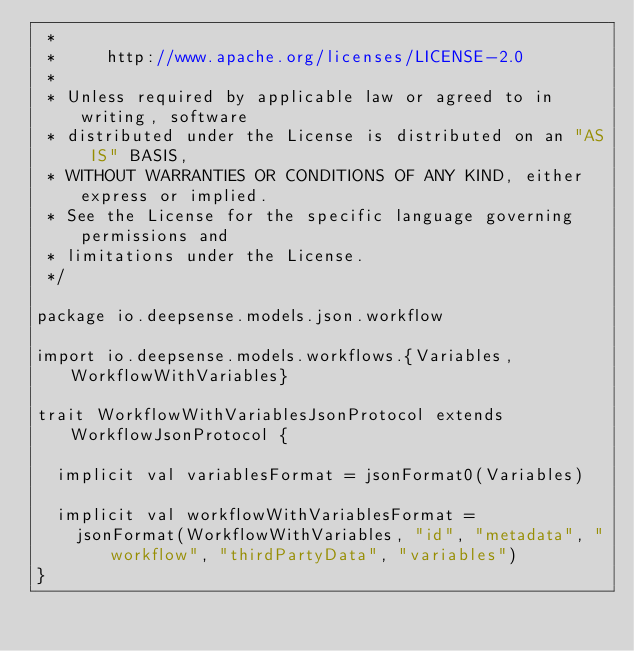<code> <loc_0><loc_0><loc_500><loc_500><_Scala_> *
 *     http://www.apache.org/licenses/LICENSE-2.0
 *
 * Unless required by applicable law or agreed to in writing, software
 * distributed under the License is distributed on an "AS IS" BASIS,
 * WITHOUT WARRANTIES OR CONDITIONS OF ANY KIND, either express or implied.
 * See the License for the specific language governing permissions and
 * limitations under the License.
 */

package io.deepsense.models.json.workflow

import io.deepsense.models.workflows.{Variables, WorkflowWithVariables}

trait WorkflowWithVariablesJsonProtocol extends WorkflowJsonProtocol {

  implicit val variablesFormat = jsonFormat0(Variables)

  implicit val workflowWithVariablesFormat =
    jsonFormat(WorkflowWithVariables, "id", "metadata", "workflow", "thirdPartyData", "variables")
}
</code> 